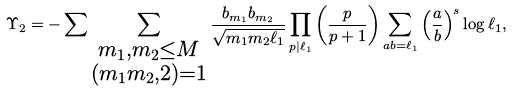Convert formula to latex. <formula><loc_0><loc_0><loc_500><loc_500>\Upsilon _ { 2 } = - \sum \sum _ { \substack { m _ { 1 } , m _ { 2 } \leq M \\ ( m _ { 1 } m _ { 2 } , 2 ) = 1 } } \frac { b _ { m _ { 1 } } b _ { m _ { 2 } } } { \sqrt { m _ { 1 } m _ { 2 } \ell _ { 1 } } } \prod _ { p | \ell _ { 1 } } \left ( \frac { p } { p + 1 } \right ) \sum _ { a b = \ell _ { 1 } } \left ( \frac { a } { b } \right ) ^ { s } \log \ell _ { 1 } ,</formula> 